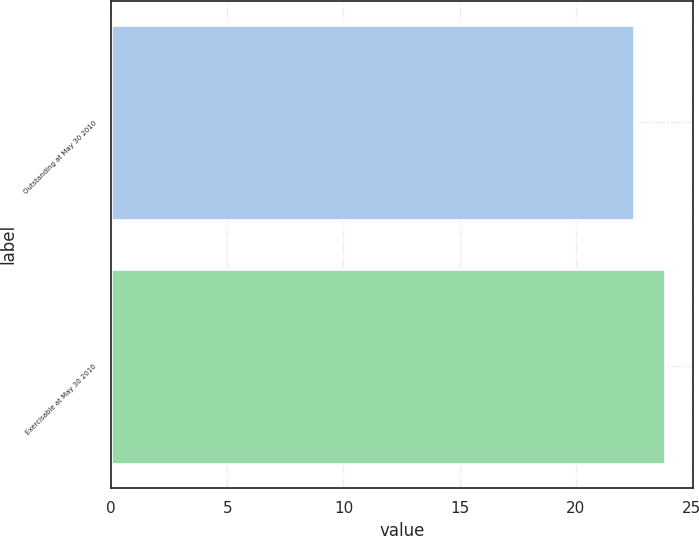<chart> <loc_0><loc_0><loc_500><loc_500><bar_chart><fcel>Outstanding at May 30 2010<fcel>Exercisable at May 30 2010<nl><fcel>22.49<fcel>23.86<nl></chart> 